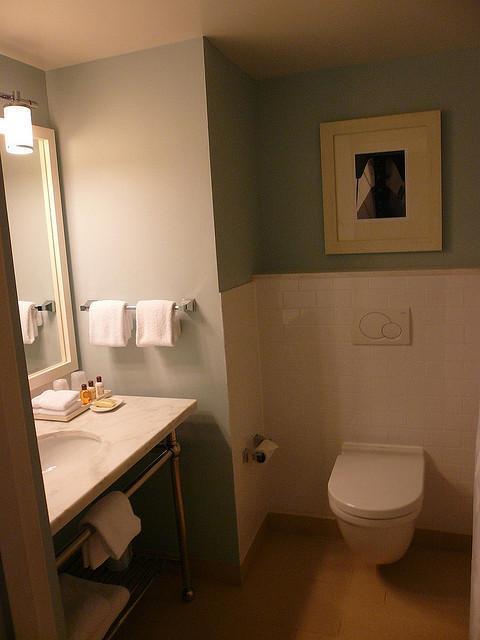How many men are holding yellow boards?
Give a very brief answer. 0. 